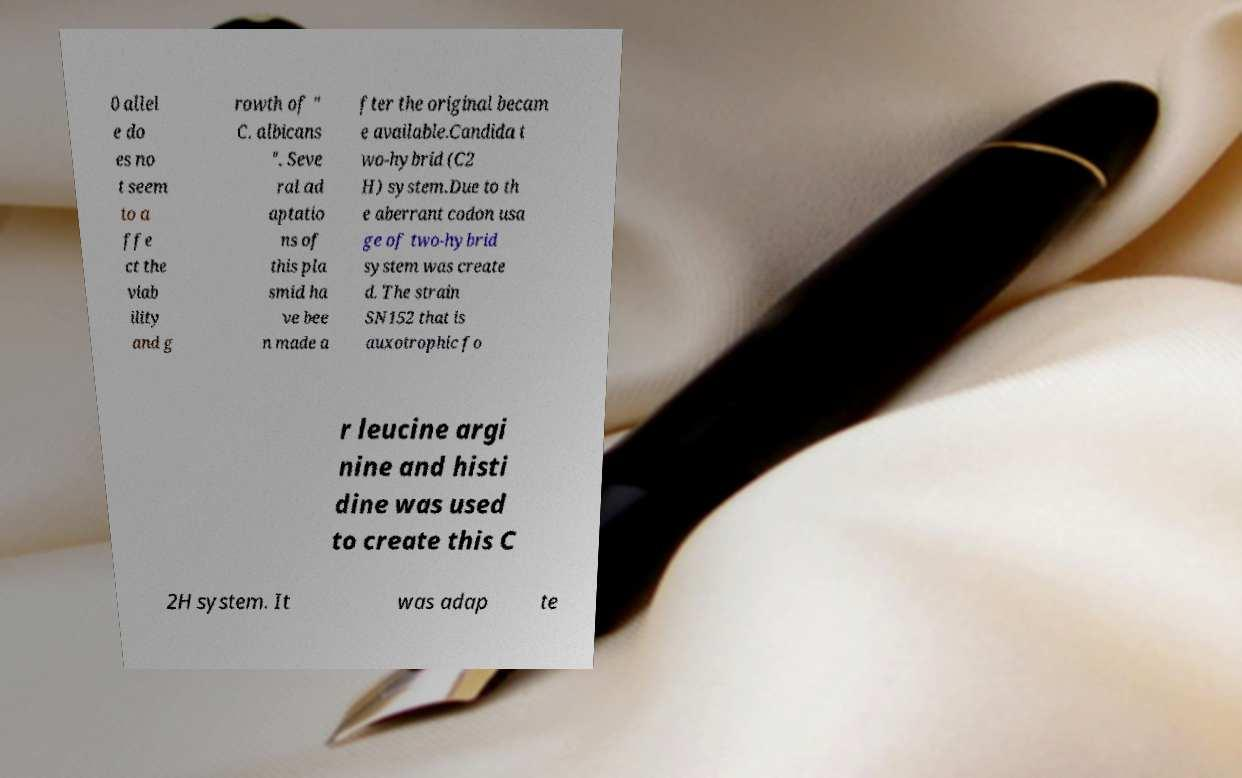What messages or text are displayed in this image? I need them in a readable, typed format. 0 allel e do es no t seem to a ffe ct the viab ility and g rowth of " C. albicans ". Seve ral ad aptatio ns of this pla smid ha ve bee n made a fter the original becam e available.Candida t wo-hybrid (C2 H) system.Due to th e aberrant codon usa ge of two-hybrid system was create d. The strain SN152 that is auxotrophic fo r leucine argi nine and histi dine was used to create this C 2H system. It was adap te 